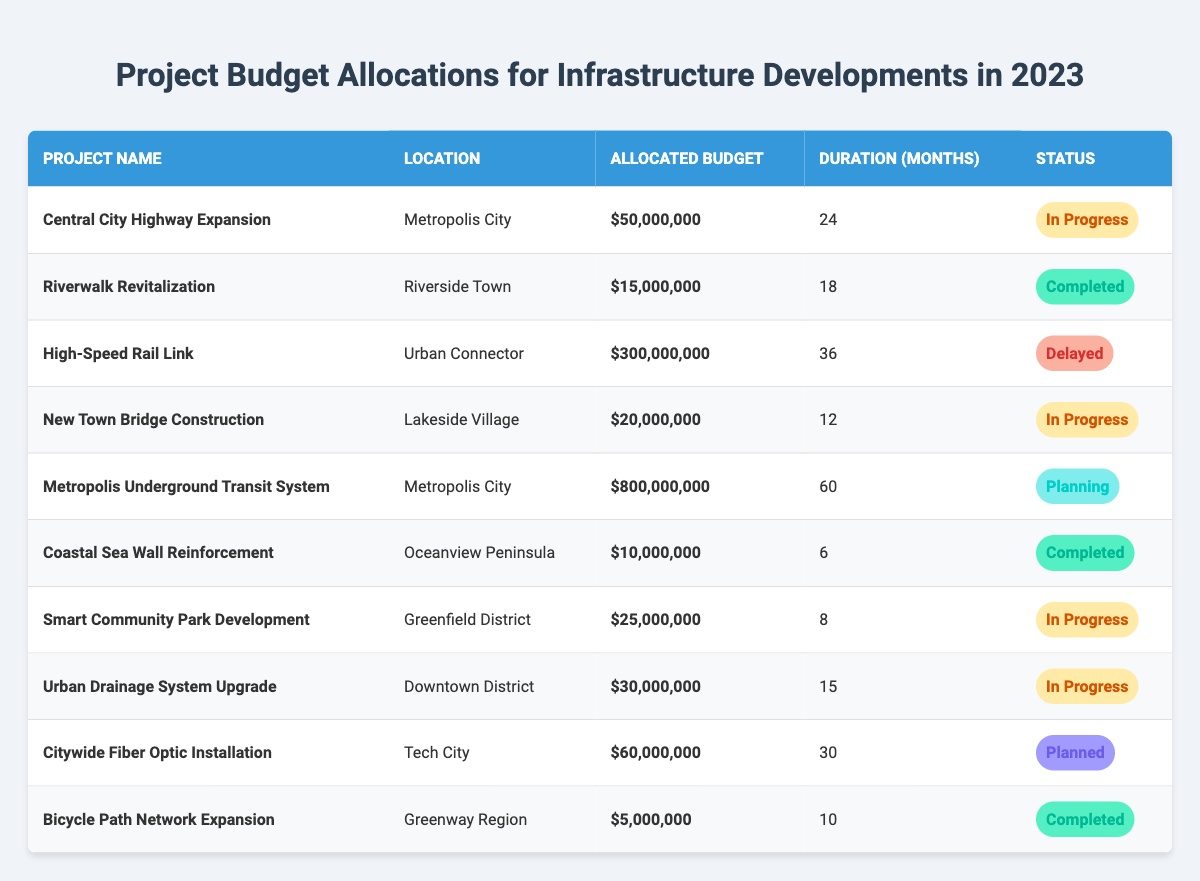What is the allocated budget for the High-Speed Rail Link project? The allocated budget for the High-Speed Rail Link project is clearly marked in the table as $300,000,000.
Answer: $300,000,000 How many infrastructure projects are currently in progress? The table lists the projects with their statuses. There are three projects marked as "In Progress": "Central City Highway Expansion," "New Town Bridge Construction," and "Smart Community Park Development."
Answer: 3 What is the total allocated budget for completed projects? The completed projects are "Riverwalk Revitalization," "Coastal Sea Wall Reinforcement," and "Bicycle Path Network Expansion," with budgets of $15,000,000, $10,000,000, and $5,000,000 respectively. Summing these budgets gives $15,000,000 + $10,000,000 + $5,000,000 = $30,000,000.
Answer: $30,000,000 Does the Metropolis Underground Transit System project have a completion status of "Completed"? The Metropolis Underground Transit System project has a completion status of "Planning," thus it is not completed.
Answer: No Which project has the longest duration, and what is that duration? The project with the longest duration is the Metropolis Underground Transit System, which has a duration of 60 months, as stated in the table.
Answer: 60 months What is the average allocated budget for projects that are still in progress? There are three projects in progress with allocated budgets of $50,000,000, $20,000,000, and $25,000,000. The average budget is calculated as ($50,000,000 + $20,000,000 + $25,000,000) / 3 = $95,000,000 / 3 ≈ $31,666,667.
Answer: $31,666,667 How does the budget for the Citywide Fiber Optic Installation compare to the budget for the Coastal Sea Wall Reinforcement? The Citywide Fiber Optic Installation has an allocated budget of $60,000,000, while the Coastal Sea Wall Reinforcement has a budget of $10,000,000. Therefore, the fiber optic project has $60,000,000 - $10,000,000 = $50,000,000 more allocated.
Answer: $50,000,000 more What is the ratio of the budget allocation of the High-Speed Rail Link project to the New Town Bridge Construction project? The High-Speed Rail Link has an allocated budget of $300,000,000 and the New Town Bridge Construction has $20,000,000. The ratio is $300,000,000 / $20,000,000 = 15.
Answer: 15 Which project has the least allocated budget, and what is it? The project with the least allocated budget is the Bicycle Path Network Expansion, with an allocated budget of $5,000,000 as per the table.
Answer: $5,000,000 Is the Coastal Sea Wall Reinforcement project shorter in duration than the Riverwalk Revitalization project? The Coastal Sea Wall Reinforcement has a duration of 6 months, while the Riverwalk Revitalization has a duration of 18 months; therefore, the Coastal Sea Wall Reinforcement is indeed shorter in duration.
Answer: Yes 